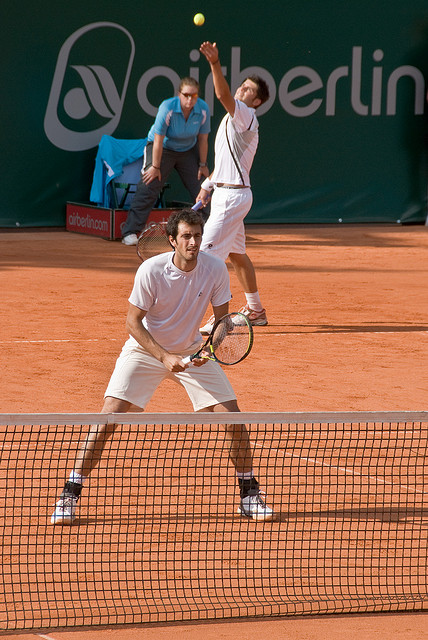Read and extract the text from this image. airberlin 